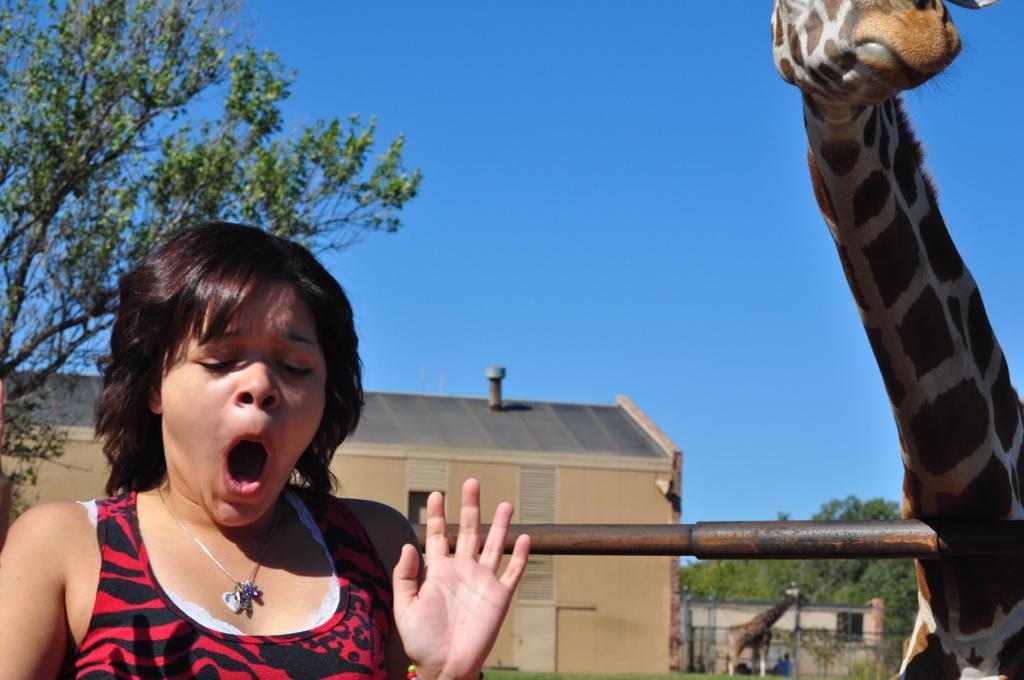How would you summarize this image in a sentence or two? In this image there is a person, two giraffes , and in the background there are buildings, trees, sky. 